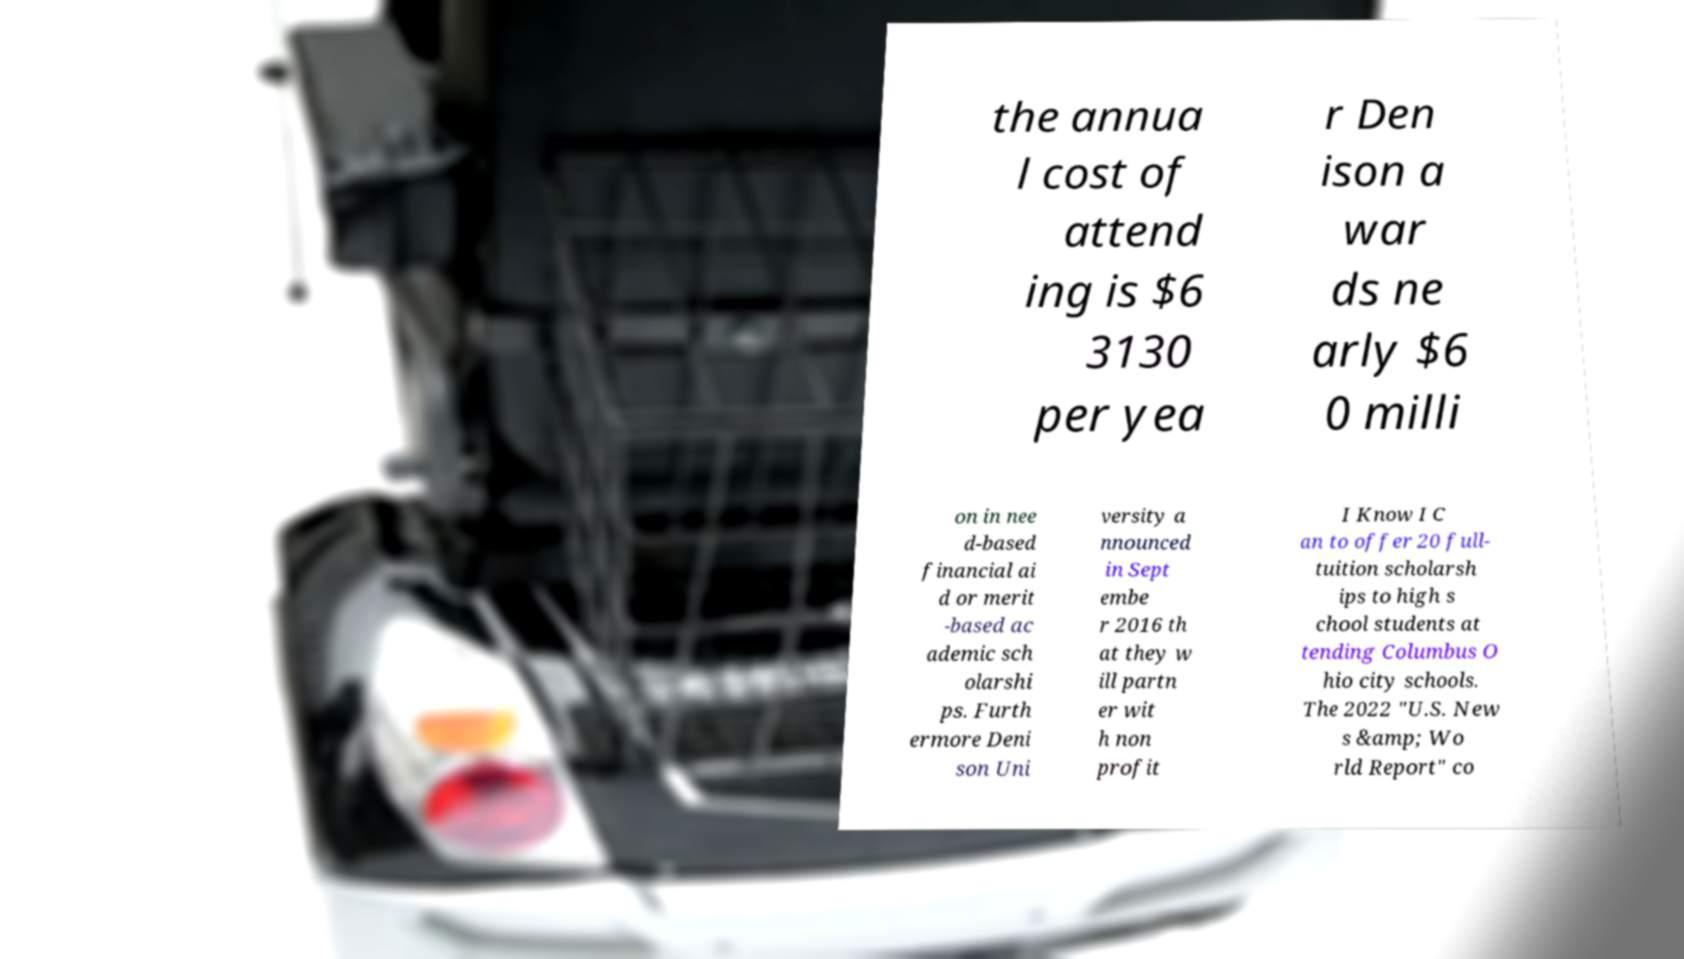Can you accurately transcribe the text from the provided image for me? the annua l cost of attend ing is $6 3130 per yea r Den ison a war ds ne arly $6 0 milli on in nee d-based financial ai d or merit -based ac ademic sch olarshi ps. Furth ermore Deni son Uni versity a nnounced in Sept embe r 2016 th at they w ill partn er wit h non profit I Know I C an to offer 20 full- tuition scholarsh ips to high s chool students at tending Columbus O hio city schools. The 2022 "U.S. New s &amp; Wo rld Report" co 